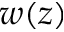<formula> <loc_0><loc_0><loc_500><loc_500>w ( z )</formula> 